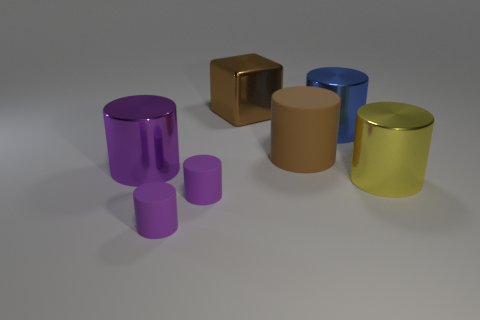What number of balls are either large metal things or blue objects?
Your answer should be very brief. 0. Is there a brown metallic object that has the same shape as the large rubber object?
Your response must be concise. No. What shape is the yellow metal thing?
Provide a succinct answer. Cylinder. What number of things are either purple shiny cylinders or small purple objects?
Your answer should be compact. 3. Does the metal thing left of the large cube have the same size as the metallic cylinder behind the brown rubber thing?
Offer a terse response. Yes. What number of other things are there of the same material as the big yellow cylinder
Offer a terse response. 3. Is the number of large matte cylinders that are behind the cube greater than the number of purple shiny cylinders on the right side of the purple metal object?
Keep it short and to the point. No. What material is the large object in front of the big purple object?
Your response must be concise. Metal. Does the large matte object have the same shape as the large purple shiny thing?
Your response must be concise. Yes. Is there any other thing that has the same color as the large metallic cube?
Make the answer very short. Yes. 